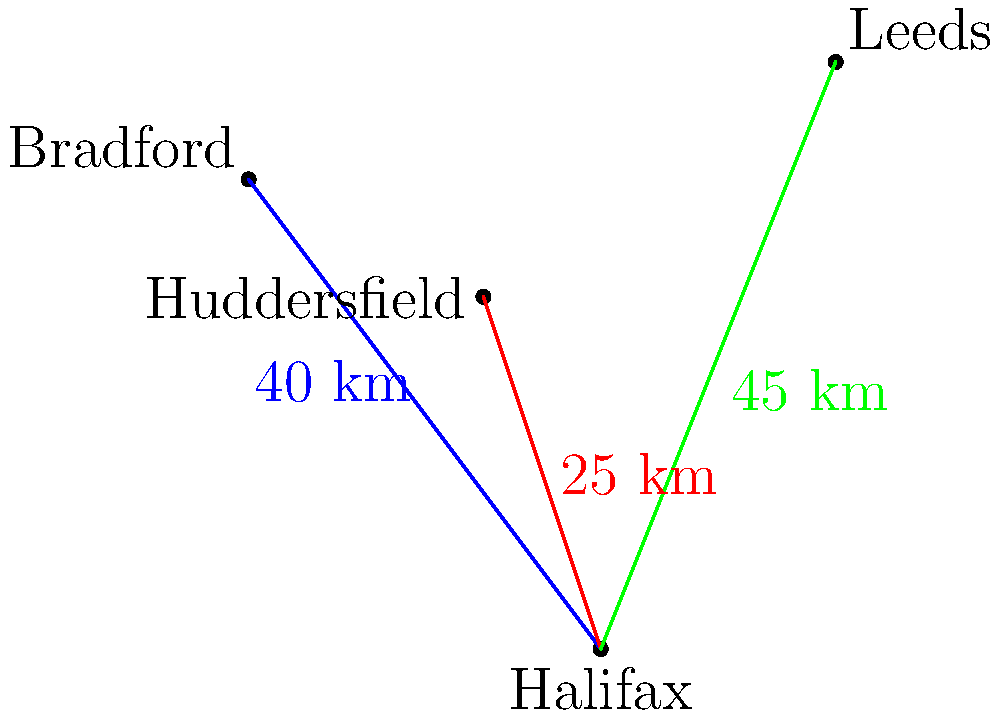Based on the map showing the distances between FC Halifax Town's home stadium and rival team stadiums, which rival team's stadium is closest to FC Halifax Town's home ground? To determine which rival team's stadium is closest to FC Halifax Town's home ground, we need to compare the distances provided on the map:

1. FC Halifax Town to Bradford: 40 km
2. FC Halifax Town to Huddersfield: 25 km
3. FC Halifax Town to Leeds: 45 km

Comparing these distances:
- 25 km < 40 km < 45 km

Therefore, Huddersfield's stadium is the closest to FC Halifax Town's home ground at 25 km.
Answer: Huddersfield 